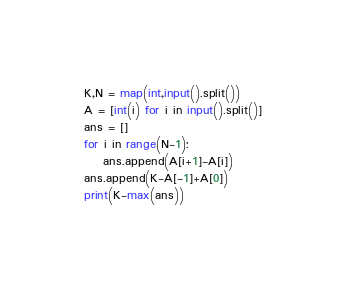<code> <loc_0><loc_0><loc_500><loc_500><_Python_>K,N = map(int,input().split())
A = [int(i) for i in input().split()]
ans = []
for i in range(N-1):
    ans.append(A[i+1]-A[i])
ans.append(K-A[-1]+A[0])
print(K-max(ans))</code> 